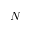<formula> <loc_0><loc_0><loc_500><loc_500>N</formula> 